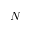<formula> <loc_0><loc_0><loc_500><loc_500>N</formula> 